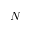<formula> <loc_0><loc_0><loc_500><loc_500>N</formula> 